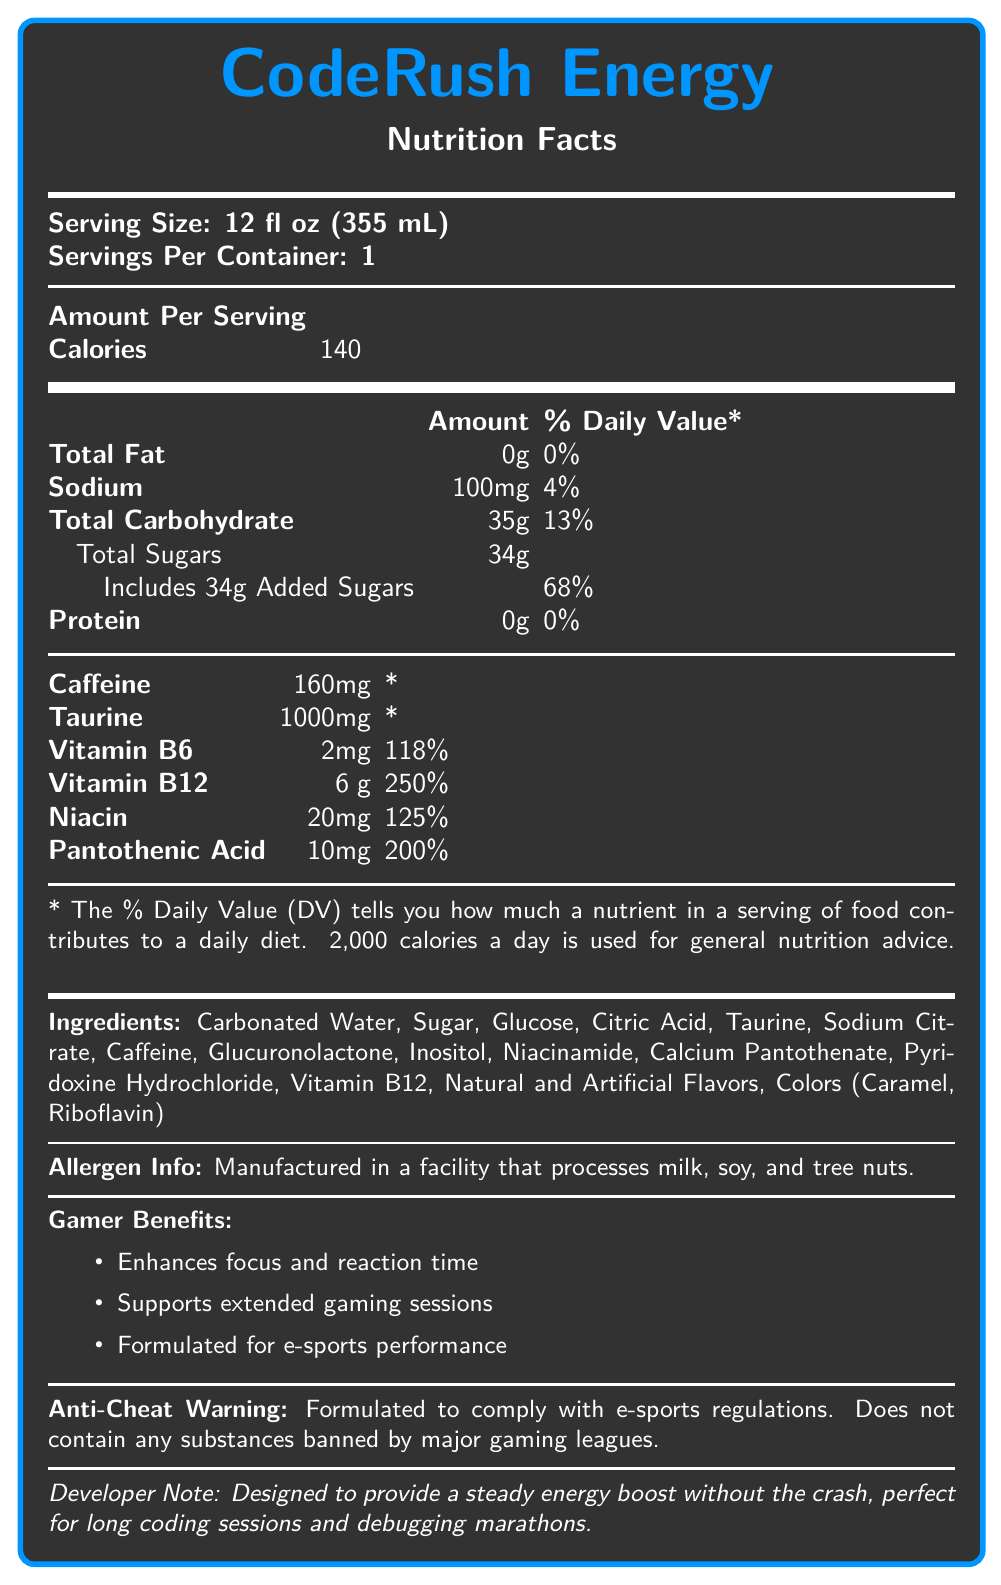what is the serving size of CodeRush Energy? The serving size is mentioned at the top of the Nutrition Facts section.
Answer: 12 fl oz (355 mL) how many calories does one serving of CodeRush Energy contain? The amount of calories per serving is listed in the 'Amount Per Serving' section.
Answer: 140 what percentage of the daily value for sodium does one serving provide? The sodium section shows that 100mg corresponds to 4% of the daily value.
Answer: 4% how much caffeine is in one serving of CodeRush Energy? The amount of caffeine per serving is explicitly stated in the caffeine section.
Answer: 160mg what is the main benefit of the product according to the developer note? The benefit mentioned is 'Designed to provide a steady energy boost without the crash.'
Answer: Provides a steady energy boost without the crash what percentage of the daily value for vitamin B12 does one serving of CodeRush Energy provide? It is listed under the vitamin B12 section.
Answer: 250% which ingredient is listed first in CodeRush Energy? The ingredients are listed starting with Carbonated Water.
Answer: Carbonated Water does the product contain any protein? Yes/No The protein section lists 0g and 0% daily value for protein.
Answer: No which of the following is not an ingredient in CodeRush Energy? A. Taurine B. Citric Acid C. Whipping Cream D. Inositol Whipping Cream is not listed in the ingredients section.
Answer: C. Whipping Cream how much total carbohydrate does one serving contain? The total carbohydrate content is 35g per serving, as indicated in the document.
Answer: 35g which vitamin has the highest percentage of daily value in one serving? Vitamin B12 provides the highest percentage of daily value at 250%.
Answer: Vitamin B12 does CodeRush Energy contain any substances banned by major gaming leagues? The anti-cheat warning states that the product does not contain any substances banned by major gaming leagues.
Answer: No what's stated under 'Gamer Benefits'? List one. One of the gamer benefits listed is enhancing focus and reaction time.
Answer: Enhances focus and reaction time how much taurine is in CodeRush Energy? The amount of taurine per serving is listed as 1000mg.
Answer: 1000mg what should one do if they're allergic to milk, soy, or tree nuts? The allergen info states that the product is manufactured in a facility that processes milk, soy, and tree nuts, implying it should be avoided by those with allergies to these.
Answer: Avoid consumption summarize the main idea of the document. The document provides a comprehensive overview of CodeRush Energy's nutritional profile, ingredients, allergen information, and gamer-specific benefits, highlighting its suitability for gamers and coders.
Answer: CodeRush Energy is a gamer-focused energy drink that provides detailed nutritional information, including high doses of caffeine and taurine, various vitamins, and an anti-cheat guarantee. It's designed to enhance focus, support extended gaming, and provide energy without a crash. what are the possible long-term effects of consuming high levels of caffeine? The document lists the caffeine content but does not provide information on the potential long-term effects of high caffeine consumption.
Answer: Not enough information 